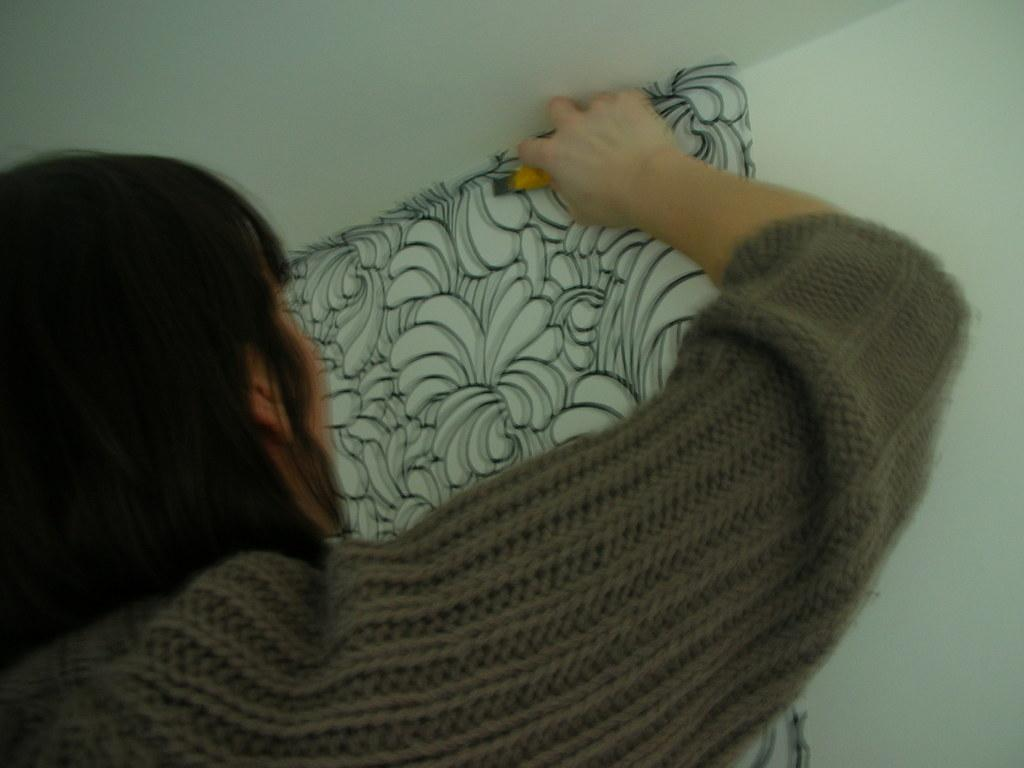What is the main subject of the image? There is a person in the image. What is the person wearing? The person is wearing a grey dress. What activity is the person engaged in? The person is pasting a sticker to the wall. What is the color of the wall? The wall is white in color. Where is the playground located in the image? There is no playground present in the image; it features a person pasting a sticker to a white wall. What type of pen is the person using to paste the sticker? The provided facts do not mention a pen being used; the person is simply pasting a sticker to the wall. 